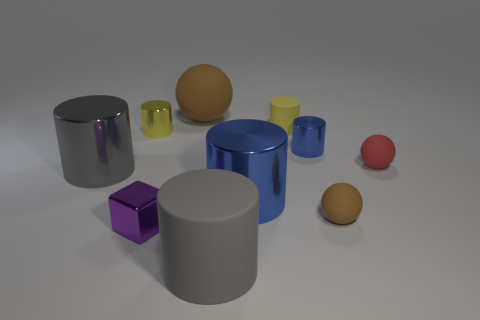Does the blue object behind the tiny red thing have the same shape as the big gray shiny thing?
Keep it short and to the point. Yes. Is there anything else that is made of the same material as the large blue thing?
Offer a very short reply. Yes. There is a purple thing; is it the same size as the brown matte thing in front of the tiny red sphere?
Offer a very short reply. Yes. What number of other things are the same color as the tiny rubber cylinder?
Keep it short and to the point. 1. There is a small yellow metallic object; are there any big gray matte objects right of it?
Give a very brief answer. Yes. What number of things are either big gray metal objects or rubber things on the right side of the large ball?
Offer a very short reply. 5. There is a brown matte ball in front of the tiny yellow matte thing; is there a small yellow matte object in front of it?
Ensure brevity in your answer.  No. There is a blue metallic object on the left side of the blue metallic object that is behind the large gray cylinder to the left of the large brown rubber sphere; what shape is it?
Keep it short and to the point. Cylinder. The object that is both to the left of the tiny brown rubber thing and right of the small rubber cylinder is what color?
Make the answer very short. Blue. What is the shape of the gray object that is on the right side of the small yellow shiny thing?
Your answer should be very brief. Cylinder. 